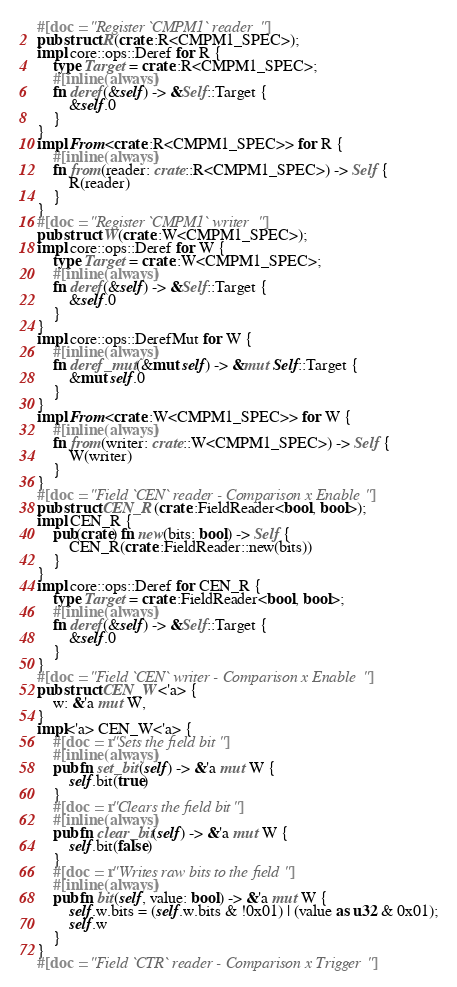<code> <loc_0><loc_0><loc_500><loc_500><_Rust_>#[doc = "Register `CMPM1` reader"]
pub struct R(crate::R<CMPM1_SPEC>);
impl core::ops::Deref for R {
    type Target = crate::R<CMPM1_SPEC>;
    #[inline(always)]
    fn deref(&self) -> &Self::Target {
        &self.0
    }
}
impl From<crate::R<CMPM1_SPEC>> for R {
    #[inline(always)]
    fn from(reader: crate::R<CMPM1_SPEC>) -> Self {
        R(reader)
    }
}
#[doc = "Register `CMPM1` writer"]
pub struct W(crate::W<CMPM1_SPEC>);
impl core::ops::Deref for W {
    type Target = crate::W<CMPM1_SPEC>;
    #[inline(always)]
    fn deref(&self) -> &Self::Target {
        &self.0
    }
}
impl core::ops::DerefMut for W {
    #[inline(always)]
    fn deref_mut(&mut self) -> &mut Self::Target {
        &mut self.0
    }
}
impl From<crate::W<CMPM1_SPEC>> for W {
    #[inline(always)]
    fn from(writer: crate::W<CMPM1_SPEC>) -> Self {
        W(writer)
    }
}
#[doc = "Field `CEN` reader - Comparison x Enable"]
pub struct CEN_R(crate::FieldReader<bool, bool>);
impl CEN_R {
    pub(crate) fn new(bits: bool) -> Self {
        CEN_R(crate::FieldReader::new(bits))
    }
}
impl core::ops::Deref for CEN_R {
    type Target = crate::FieldReader<bool, bool>;
    #[inline(always)]
    fn deref(&self) -> &Self::Target {
        &self.0
    }
}
#[doc = "Field `CEN` writer - Comparison x Enable"]
pub struct CEN_W<'a> {
    w: &'a mut W,
}
impl<'a> CEN_W<'a> {
    #[doc = r"Sets the field bit"]
    #[inline(always)]
    pub fn set_bit(self) -> &'a mut W {
        self.bit(true)
    }
    #[doc = r"Clears the field bit"]
    #[inline(always)]
    pub fn clear_bit(self) -> &'a mut W {
        self.bit(false)
    }
    #[doc = r"Writes raw bits to the field"]
    #[inline(always)]
    pub fn bit(self, value: bool) -> &'a mut W {
        self.w.bits = (self.w.bits & !0x01) | (value as u32 & 0x01);
        self.w
    }
}
#[doc = "Field `CTR` reader - Comparison x Trigger"]</code> 